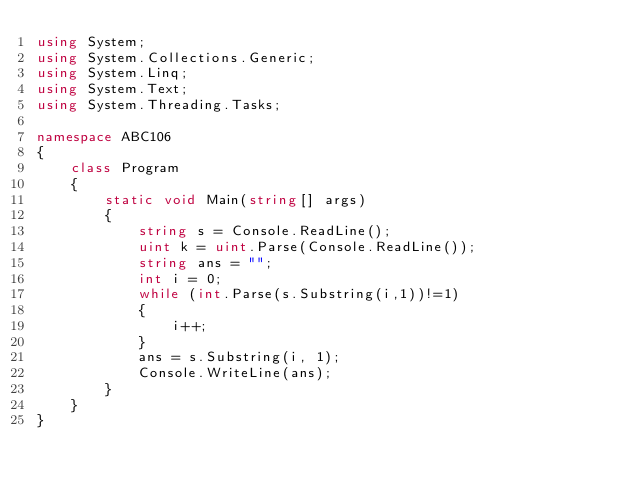Convert code to text. <code><loc_0><loc_0><loc_500><loc_500><_C#_>using System;
using System.Collections.Generic;
using System.Linq;
using System.Text;
using System.Threading.Tasks;

namespace ABC106
{
    class Program
    {
        static void Main(string[] args)
        {
            string s = Console.ReadLine();
            uint k = uint.Parse(Console.ReadLine());
            string ans = "";
            int i = 0;
            while (int.Parse(s.Substring(i,1))!=1)
            {
                i++;
            }
            ans = s.Substring(i, 1);
            Console.WriteLine(ans);
        }
    }
}
</code> 